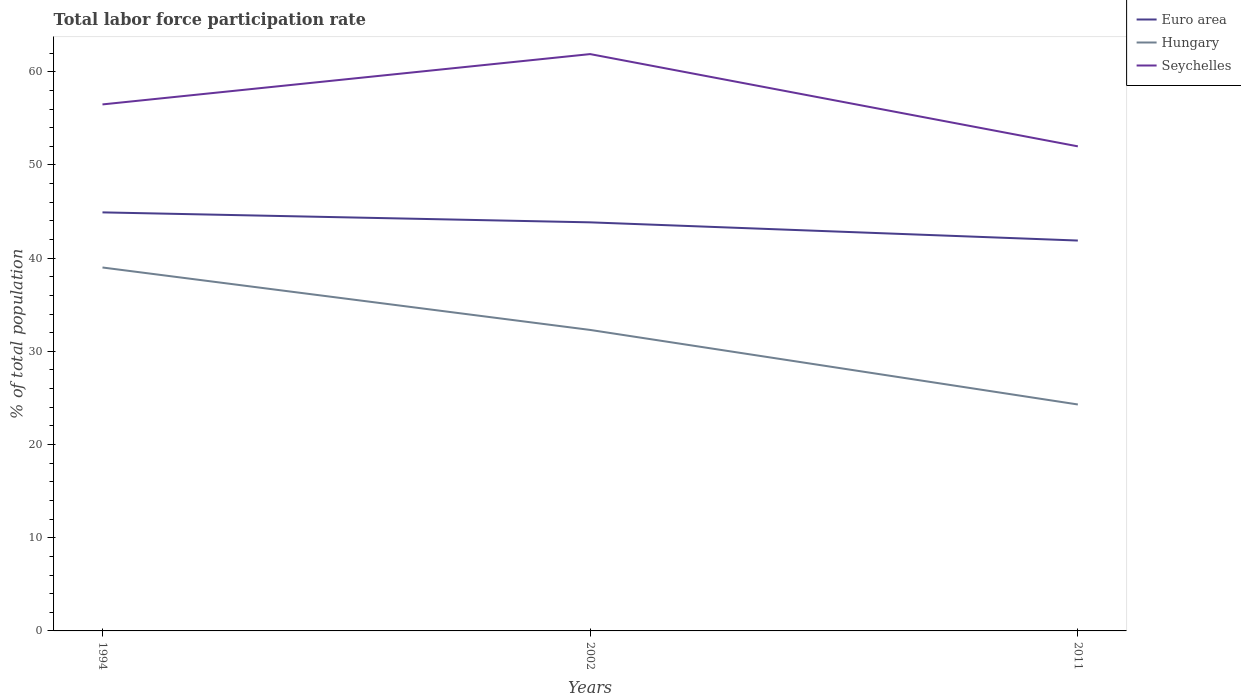Does the line corresponding to Hungary intersect with the line corresponding to Seychelles?
Make the answer very short. No. Across all years, what is the maximum total labor force participation rate in Seychelles?
Give a very brief answer. 52. What is the total total labor force participation rate in Hungary in the graph?
Offer a terse response. 8. What is the difference between the highest and the second highest total labor force participation rate in Euro area?
Provide a short and direct response. 3.02. What is the difference between the highest and the lowest total labor force participation rate in Seychelles?
Ensure brevity in your answer.  1. What is the difference between two consecutive major ticks on the Y-axis?
Ensure brevity in your answer.  10. Does the graph contain any zero values?
Offer a very short reply. No. Does the graph contain grids?
Give a very brief answer. No. Where does the legend appear in the graph?
Give a very brief answer. Top right. How many legend labels are there?
Offer a terse response. 3. What is the title of the graph?
Offer a terse response. Total labor force participation rate. Does "Sri Lanka" appear as one of the legend labels in the graph?
Make the answer very short. No. What is the label or title of the Y-axis?
Make the answer very short. % of total population. What is the % of total population of Euro area in 1994?
Offer a terse response. 44.91. What is the % of total population in Hungary in 1994?
Offer a terse response. 39. What is the % of total population in Seychelles in 1994?
Provide a short and direct response. 56.5. What is the % of total population in Euro area in 2002?
Your answer should be very brief. 43.84. What is the % of total population of Hungary in 2002?
Make the answer very short. 32.3. What is the % of total population in Seychelles in 2002?
Ensure brevity in your answer.  61.9. What is the % of total population in Euro area in 2011?
Your answer should be very brief. 41.89. What is the % of total population in Hungary in 2011?
Provide a short and direct response. 24.3. What is the % of total population in Seychelles in 2011?
Give a very brief answer. 52. Across all years, what is the maximum % of total population of Euro area?
Your answer should be very brief. 44.91. Across all years, what is the maximum % of total population of Seychelles?
Ensure brevity in your answer.  61.9. Across all years, what is the minimum % of total population of Euro area?
Offer a very short reply. 41.89. Across all years, what is the minimum % of total population of Hungary?
Ensure brevity in your answer.  24.3. Across all years, what is the minimum % of total population of Seychelles?
Ensure brevity in your answer.  52. What is the total % of total population in Euro area in the graph?
Make the answer very short. 130.65. What is the total % of total population of Hungary in the graph?
Make the answer very short. 95.6. What is the total % of total population in Seychelles in the graph?
Keep it short and to the point. 170.4. What is the difference between the % of total population of Euro area in 1994 and that in 2002?
Make the answer very short. 1.07. What is the difference between the % of total population in Euro area in 1994 and that in 2011?
Your answer should be very brief. 3.02. What is the difference between the % of total population of Seychelles in 1994 and that in 2011?
Your response must be concise. 4.5. What is the difference between the % of total population in Euro area in 2002 and that in 2011?
Provide a succinct answer. 1.95. What is the difference between the % of total population in Seychelles in 2002 and that in 2011?
Provide a short and direct response. 9.9. What is the difference between the % of total population in Euro area in 1994 and the % of total population in Hungary in 2002?
Your answer should be very brief. 12.61. What is the difference between the % of total population of Euro area in 1994 and the % of total population of Seychelles in 2002?
Ensure brevity in your answer.  -16.99. What is the difference between the % of total population in Hungary in 1994 and the % of total population in Seychelles in 2002?
Offer a very short reply. -22.9. What is the difference between the % of total population of Euro area in 1994 and the % of total population of Hungary in 2011?
Your answer should be compact. 20.61. What is the difference between the % of total population of Euro area in 1994 and the % of total population of Seychelles in 2011?
Give a very brief answer. -7.09. What is the difference between the % of total population of Euro area in 2002 and the % of total population of Hungary in 2011?
Make the answer very short. 19.54. What is the difference between the % of total population in Euro area in 2002 and the % of total population in Seychelles in 2011?
Offer a very short reply. -8.16. What is the difference between the % of total population in Hungary in 2002 and the % of total population in Seychelles in 2011?
Keep it short and to the point. -19.7. What is the average % of total population in Euro area per year?
Provide a succinct answer. 43.55. What is the average % of total population in Hungary per year?
Give a very brief answer. 31.87. What is the average % of total population of Seychelles per year?
Offer a very short reply. 56.8. In the year 1994, what is the difference between the % of total population of Euro area and % of total population of Hungary?
Provide a succinct answer. 5.91. In the year 1994, what is the difference between the % of total population in Euro area and % of total population in Seychelles?
Provide a short and direct response. -11.59. In the year 1994, what is the difference between the % of total population in Hungary and % of total population in Seychelles?
Keep it short and to the point. -17.5. In the year 2002, what is the difference between the % of total population in Euro area and % of total population in Hungary?
Your answer should be very brief. 11.54. In the year 2002, what is the difference between the % of total population of Euro area and % of total population of Seychelles?
Your answer should be very brief. -18.06. In the year 2002, what is the difference between the % of total population in Hungary and % of total population in Seychelles?
Offer a terse response. -29.6. In the year 2011, what is the difference between the % of total population in Euro area and % of total population in Hungary?
Provide a short and direct response. 17.59. In the year 2011, what is the difference between the % of total population of Euro area and % of total population of Seychelles?
Your answer should be very brief. -10.11. In the year 2011, what is the difference between the % of total population of Hungary and % of total population of Seychelles?
Offer a terse response. -27.7. What is the ratio of the % of total population of Euro area in 1994 to that in 2002?
Your response must be concise. 1.02. What is the ratio of the % of total population of Hungary in 1994 to that in 2002?
Your answer should be compact. 1.21. What is the ratio of the % of total population of Seychelles in 1994 to that in 2002?
Your answer should be very brief. 0.91. What is the ratio of the % of total population in Euro area in 1994 to that in 2011?
Keep it short and to the point. 1.07. What is the ratio of the % of total population in Hungary in 1994 to that in 2011?
Your answer should be very brief. 1.6. What is the ratio of the % of total population of Seychelles in 1994 to that in 2011?
Keep it short and to the point. 1.09. What is the ratio of the % of total population of Euro area in 2002 to that in 2011?
Give a very brief answer. 1.05. What is the ratio of the % of total population in Hungary in 2002 to that in 2011?
Offer a terse response. 1.33. What is the ratio of the % of total population in Seychelles in 2002 to that in 2011?
Keep it short and to the point. 1.19. What is the difference between the highest and the second highest % of total population of Euro area?
Your answer should be very brief. 1.07. What is the difference between the highest and the second highest % of total population in Seychelles?
Keep it short and to the point. 5.4. What is the difference between the highest and the lowest % of total population in Euro area?
Provide a short and direct response. 3.02. 